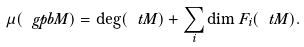Convert formula to latex. <formula><loc_0><loc_0><loc_500><loc_500>\mu ( \ g p b M ) = \deg ( \ t M ) + \sum _ { i } \dim F _ { i } ( \ t M ) .</formula> 